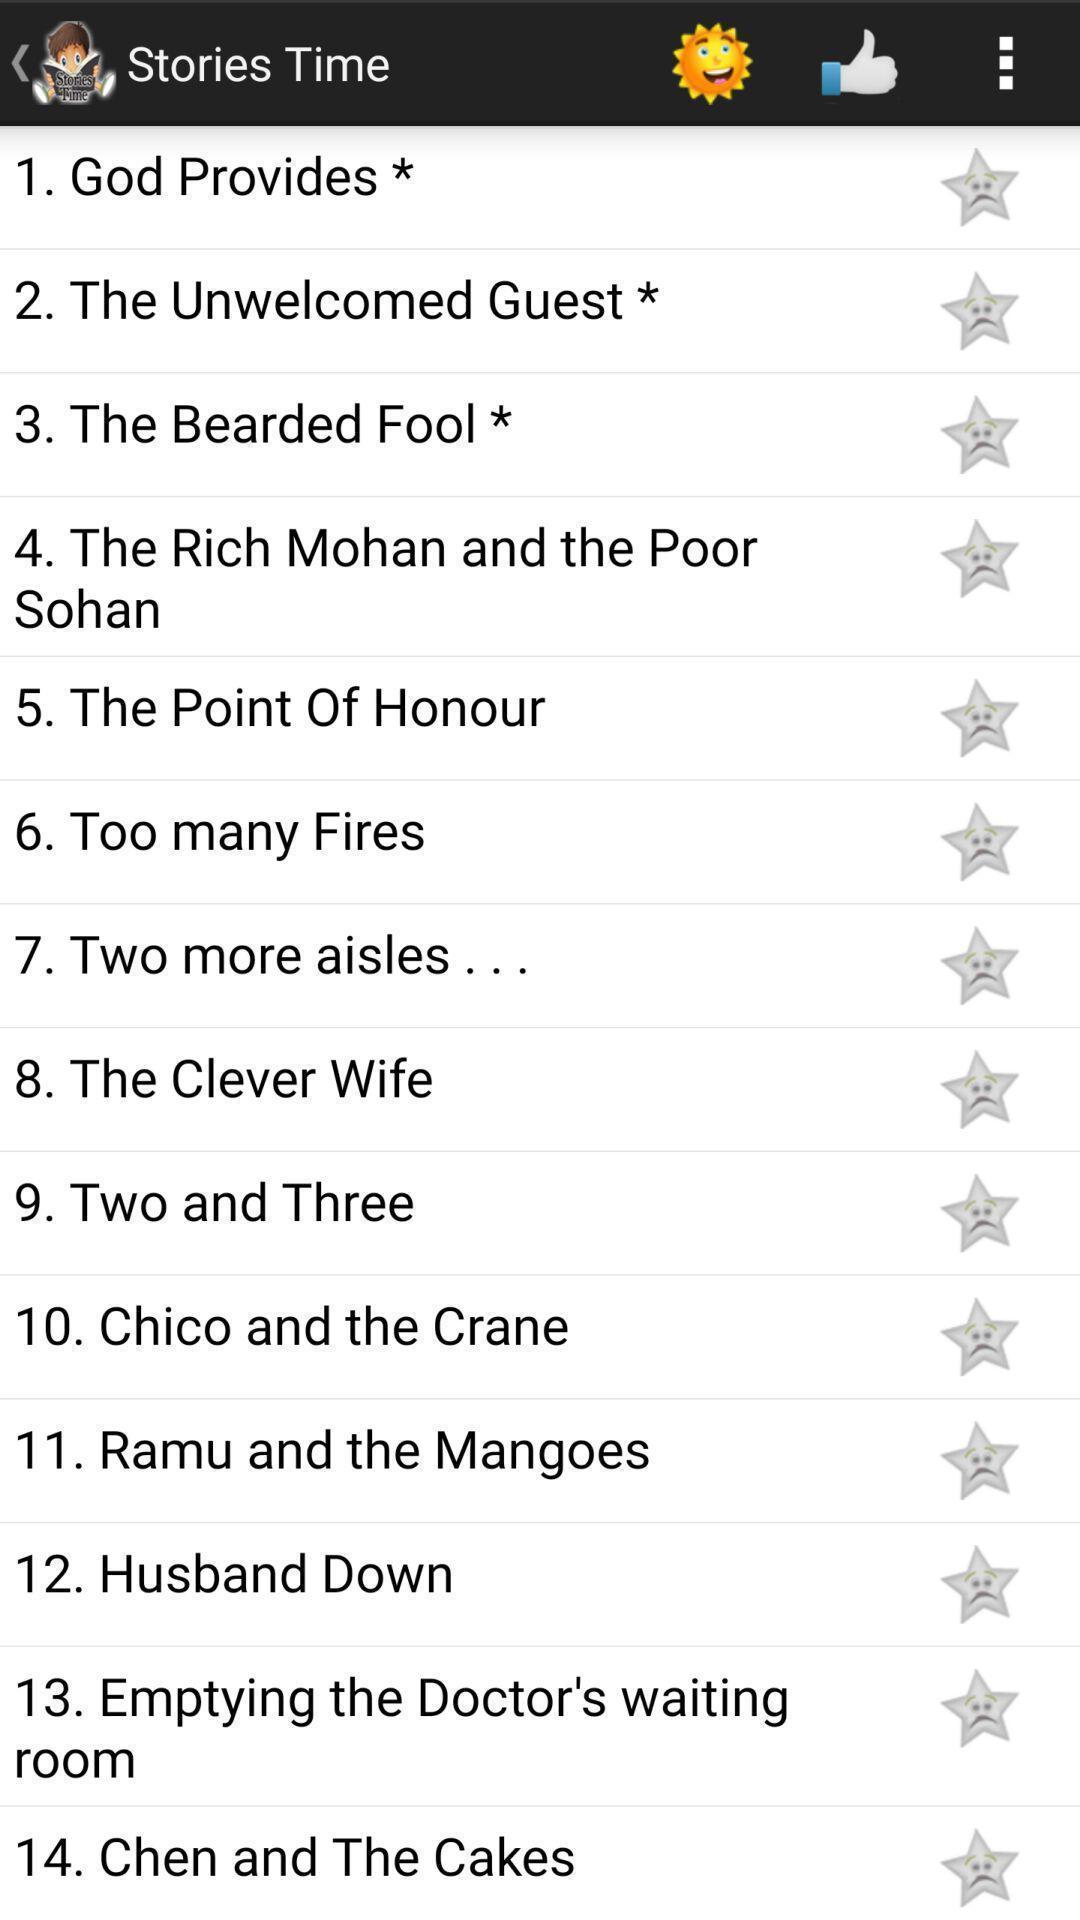Summarize the main components in this picture. Screen shows offline stories time app. 